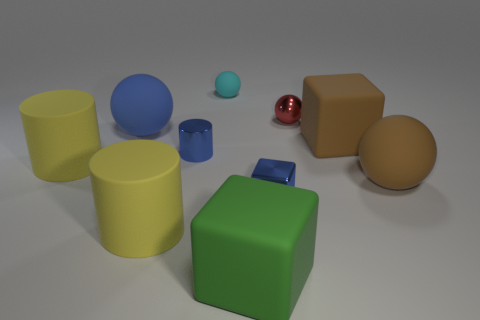Are the large cube right of the green rubber cube and the small object right of the shiny cube made of the same material?
Ensure brevity in your answer.  No. How many objects are blue spheres that are behind the brown ball or large matte things left of the small cylinder?
Ensure brevity in your answer.  3. What number of blue cubes are there?
Provide a short and direct response. 1. Are there any matte cylinders of the same size as the blue matte object?
Provide a short and direct response. Yes. Is the blue ball made of the same material as the cube to the right of the metal sphere?
Your response must be concise. Yes. There is a blue thing that is on the right side of the green object; what is its material?
Provide a short and direct response. Metal. What is the size of the green block?
Your response must be concise. Large. Do the rubber sphere to the right of the cyan matte thing and the yellow matte thing in front of the big brown ball have the same size?
Keep it short and to the point. Yes. There is a brown matte thing that is the same shape as the blue matte thing; what is its size?
Offer a terse response. Large. There is a red shiny object; does it have the same size as the rubber object that is behind the big blue thing?
Provide a short and direct response. Yes. 